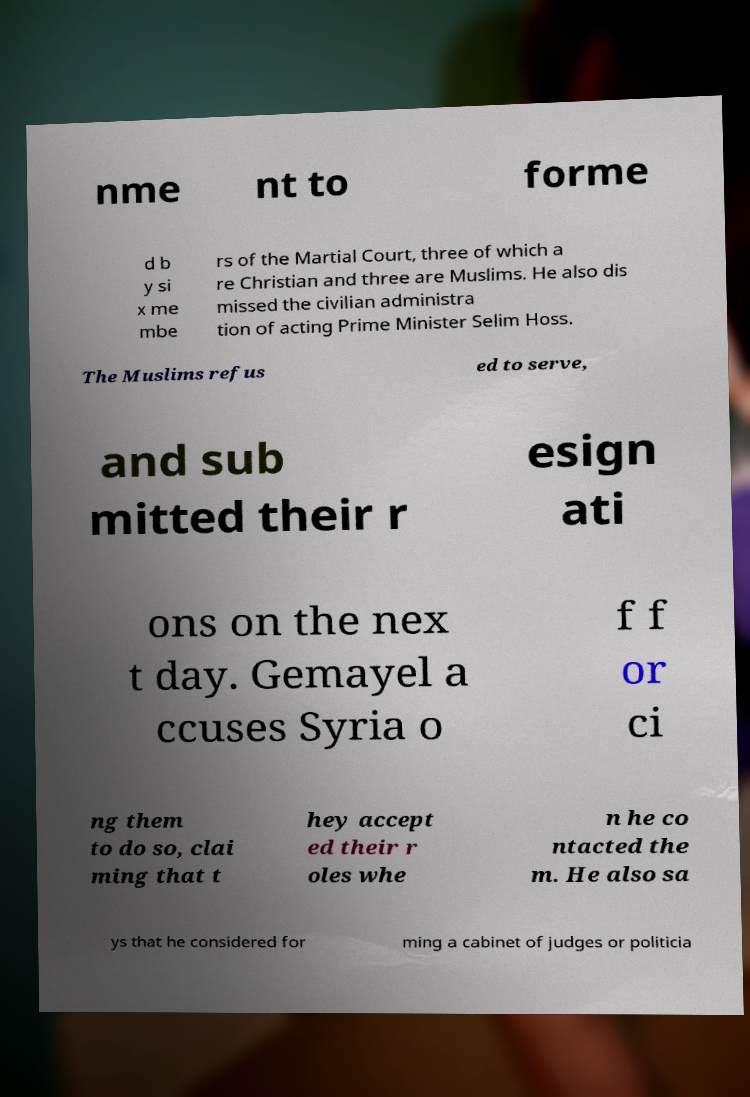What messages or text are displayed in this image? I need them in a readable, typed format. nme nt to forme d b y si x me mbe rs of the Martial Court, three of which a re Christian and three are Muslims. He also dis missed the civilian administra tion of acting Prime Minister Selim Hoss. The Muslims refus ed to serve, and sub mitted their r esign ati ons on the nex t day. Gemayel a ccuses Syria o f f or ci ng them to do so, clai ming that t hey accept ed their r oles whe n he co ntacted the m. He also sa ys that he considered for ming a cabinet of judges or politicia 